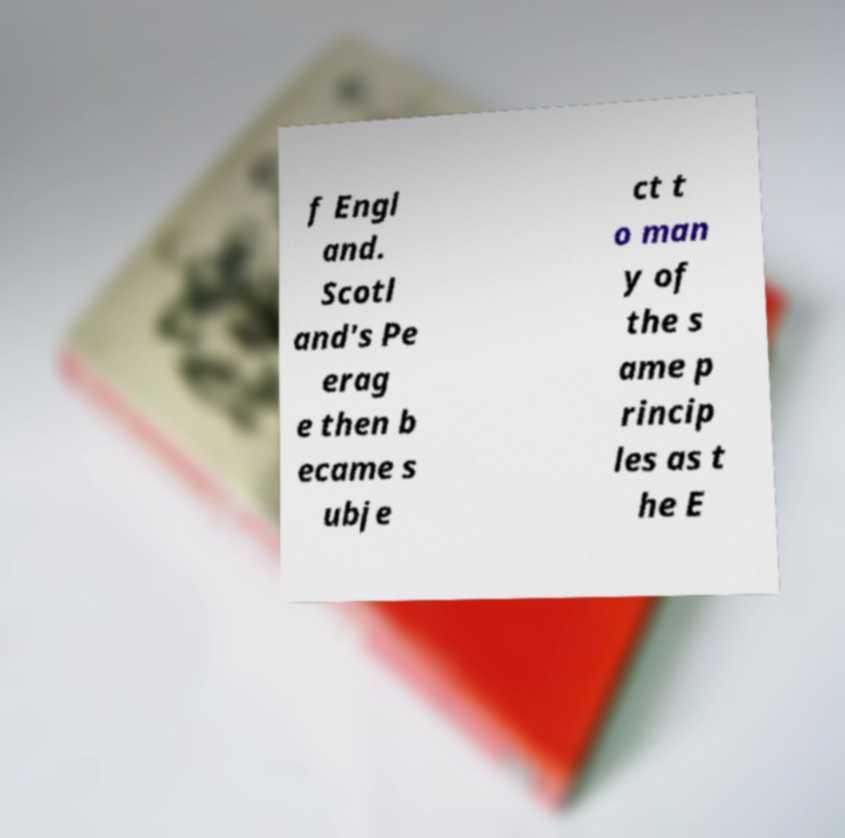Could you extract and type out the text from this image? f Engl and. Scotl and's Pe erag e then b ecame s ubje ct t o man y of the s ame p rincip les as t he E 